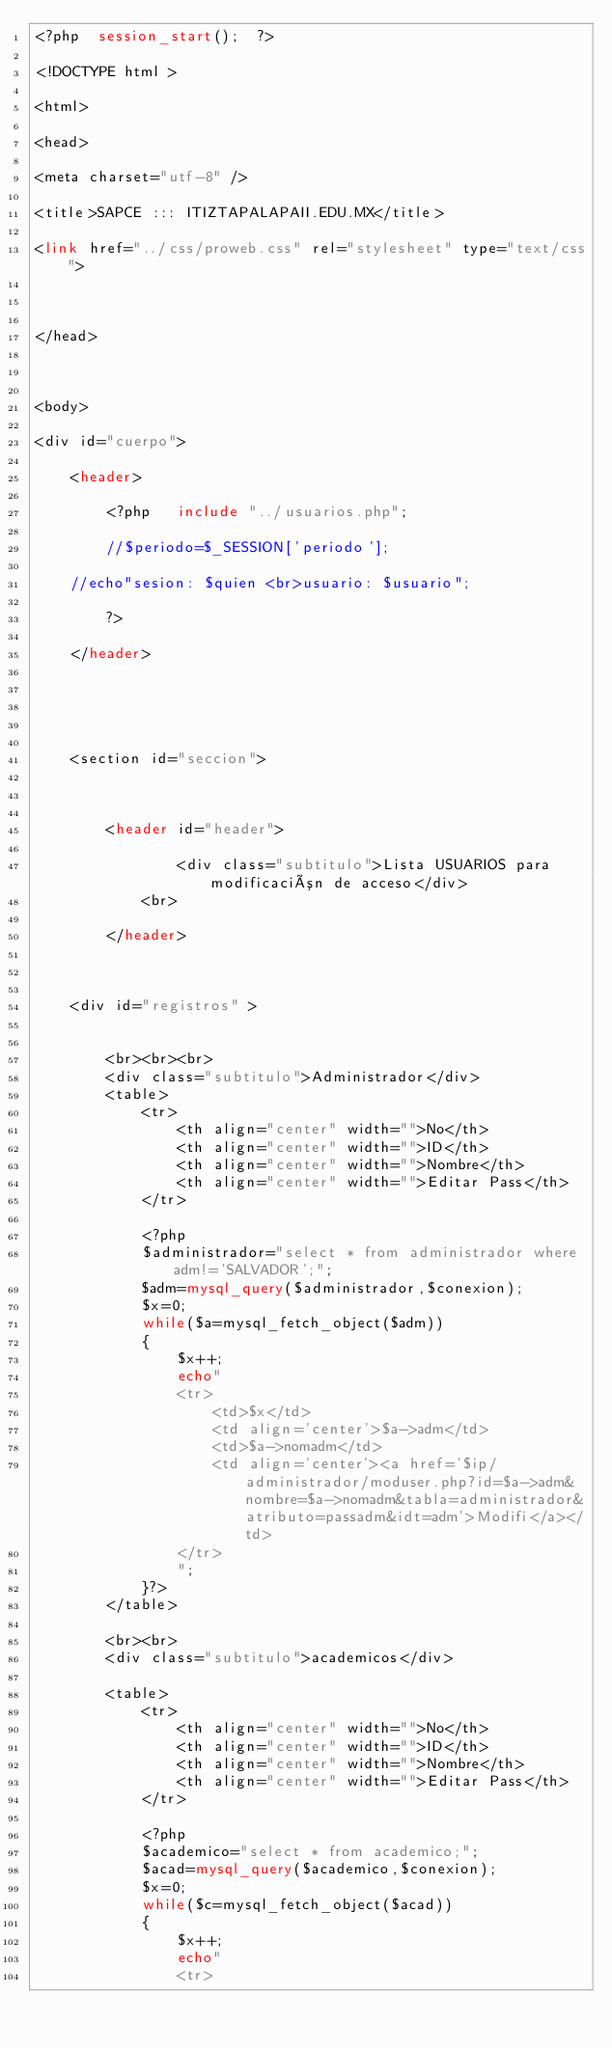<code> <loc_0><loc_0><loc_500><loc_500><_PHP_><?php  session_start();  ?>

<!DOCTYPE html >

<html>

<head>

<meta charset="utf-8" />

<title>SAPCE ::: ITIZTAPALAPAII.EDU.MX</title>

<link href="../css/proweb.css" rel="stylesheet" type="text/css">



</head>



<body>

<div id="cuerpo">

	<header>

		<?php 	include "../usuarios.php";	

		//$periodo=$_SESSION['periodo'];

	//echo"sesion: $quien <br>usuario: $usuario";

		?>

	</header>

	

	

	<section id="seccion">

    

        <header id="header">

                <div class="subtitulo">Lista USUARIOS para modificación de acceso</div>
            <br>

        </header>



    <div id="registros" >


    	<br><br><br>
        <div class="subtitulo">Administrador</div>
	    <table>
	    	<tr>
	        	<th align="center" width="">No</th>
	            <th align="center" width="">ID</th>
	            <th align="center" width="">Nombre</th>    
	            <th align="center" width="">Editar Pass</th>  
	        </tr>

	        <?php
			$administrador="select * from administrador where adm!='SALVADOR';";
			$adm=mysql_query($administrador,$conexion);
			$x=0;
			while($a=mysql_fetch_object($adm))
			{
				$x++;
				echo"
				<tr>
					<td>$x</td>
					<td align='center'>$a->adm</td>
					<td>$a->nomadm</td>			
					<td align='center'><a href='$ip/administrador/moduser.php?id=$a->adm&nombre=$a->nomadm&tabla=administrador&atributo=passadm&idt=adm'>Modifi</a></td>
				</tr>
				"; 
	    	}?>
	    </table>

	    <br><br>
        <div class="subtitulo">academicos</div>

	    <table>
	    	<tr>
	        	<th align="center" width="">No</th>
	            <th align="center" width="">ID</th>
	            <th align="center" width="">Nombre</th>    
	            <th align="center" width="">Editar Pass</th>  
	        </tr>

	        <?php
			$academico="select * from academico;";
			$acad=mysql_query($academico,$conexion);
			$x=0;
			while($c=mysql_fetch_object($acad))
			{
				$x++;
				echo"
				<tr></code> 